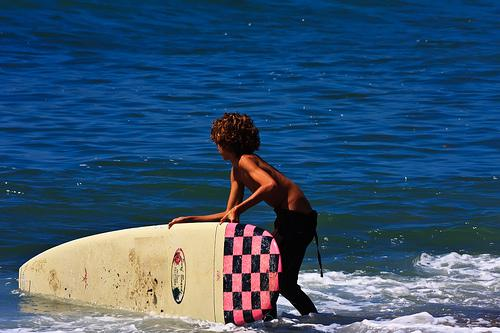Question: where is the surfboard?
Choices:
A. On the beach.
B. In the water.
C. In the van.
D. On the wall.
Answer with the letter. Answer: B Question: why is there a surfboard?
Choices:
A. Decoration.
B. Repair.
C. The boy is going surfing.
D. Competition.
Answer with the letter. Answer: C Question: who is going surfing?
Choices:
A. The man.
B. The boy.
C. The surfers.
D. The woman.
Answer with the letter. Answer: B Question: what is the weather like?
Choices:
A. Dark and stormy.
B. Cloudy.
C. Overcast.
D. Sunny.
Answer with the letter. Answer: D 